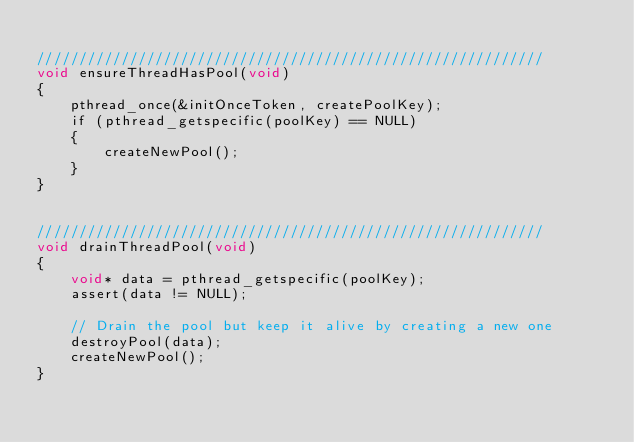Convert code to text. <code><loc_0><loc_0><loc_500><loc_500><_ObjectiveC_>
////////////////////////////////////////////////////////////
void ensureThreadHasPool(void)
{
    pthread_once(&initOnceToken, createPoolKey);
    if (pthread_getspecific(poolKey) == NULL)
    {
        createNewPool();
    }
}


////////////////////////////////////////////////////////////
void drainThreadPool(void)
{
    void* data = pthread_getspecific(poolKey);
    assert(data != NULL);

    // Drain the pool but keep it alive by creating a new one
    destroyPool(data);
    createNewPool();
}

</code> 